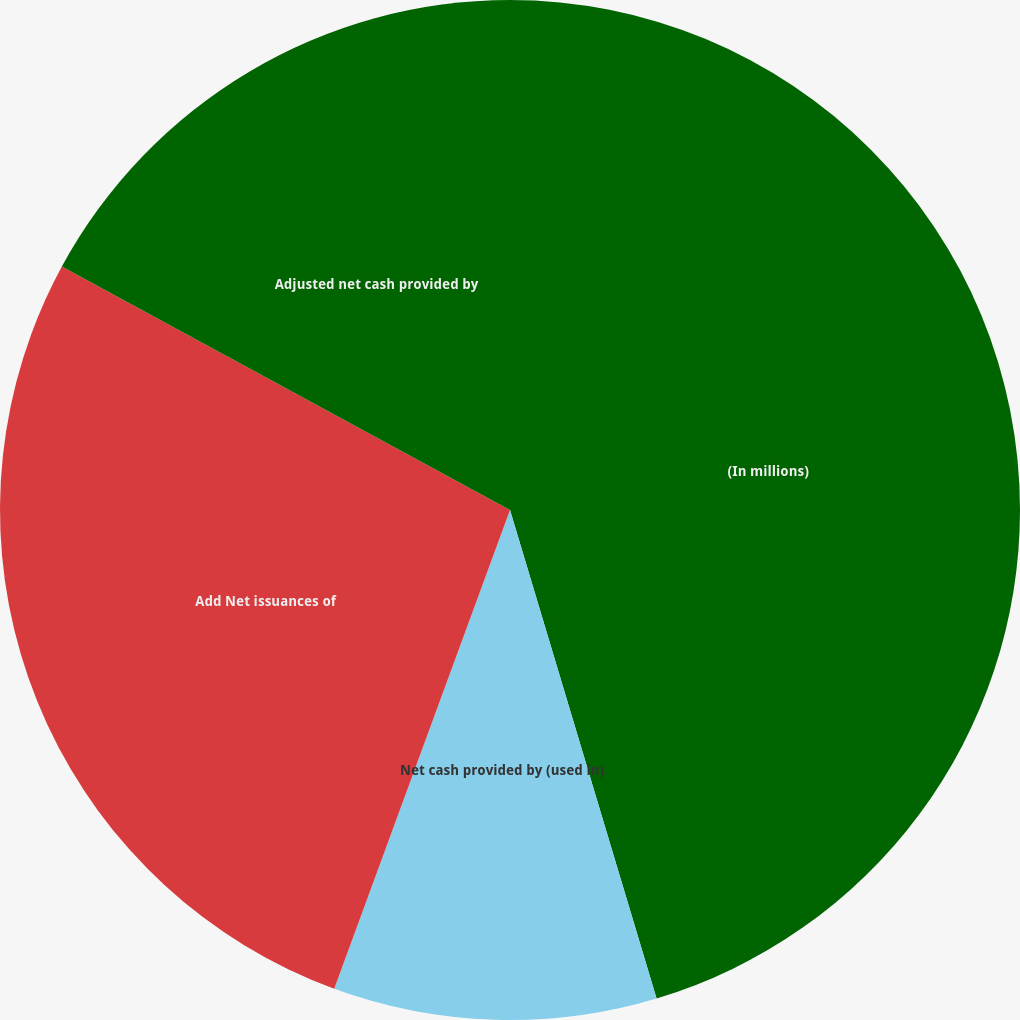Convert chart. <chart><loc_0><loc_0><loc_500><loc_500><pie_chart><fcel>(In millions)<fcel>Net cash provided by (used in)<fcel>Add Net issuances of<fcel>Adjusted net cash provided by<nl><fcel>45.36%<fcel>10.24%<fcel>27.32%<fcel>17.08%<nl></chart> 